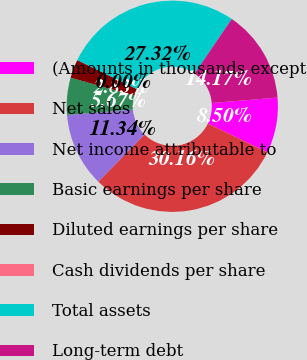Convert chart. <chart><loc_0><loc_0><loc_500><loc_500><pie_chart><fcel>(Amounts in thousands except<fcel>Net sales<fcel>Net income attributable to<fcel>Basic earnings per share<fcel>Diluted earnings per share<fcel>Cash dividends per share<fcel>Total assets<fcel>Long-term debt<nl><fcel>8.5%<fcel>30.16%<fcel>11.34%<fcel>5.67%<fcel>2.83%<fcel>0.0%<fcel>27.32%<fcel>14.17%<nl></chart> 